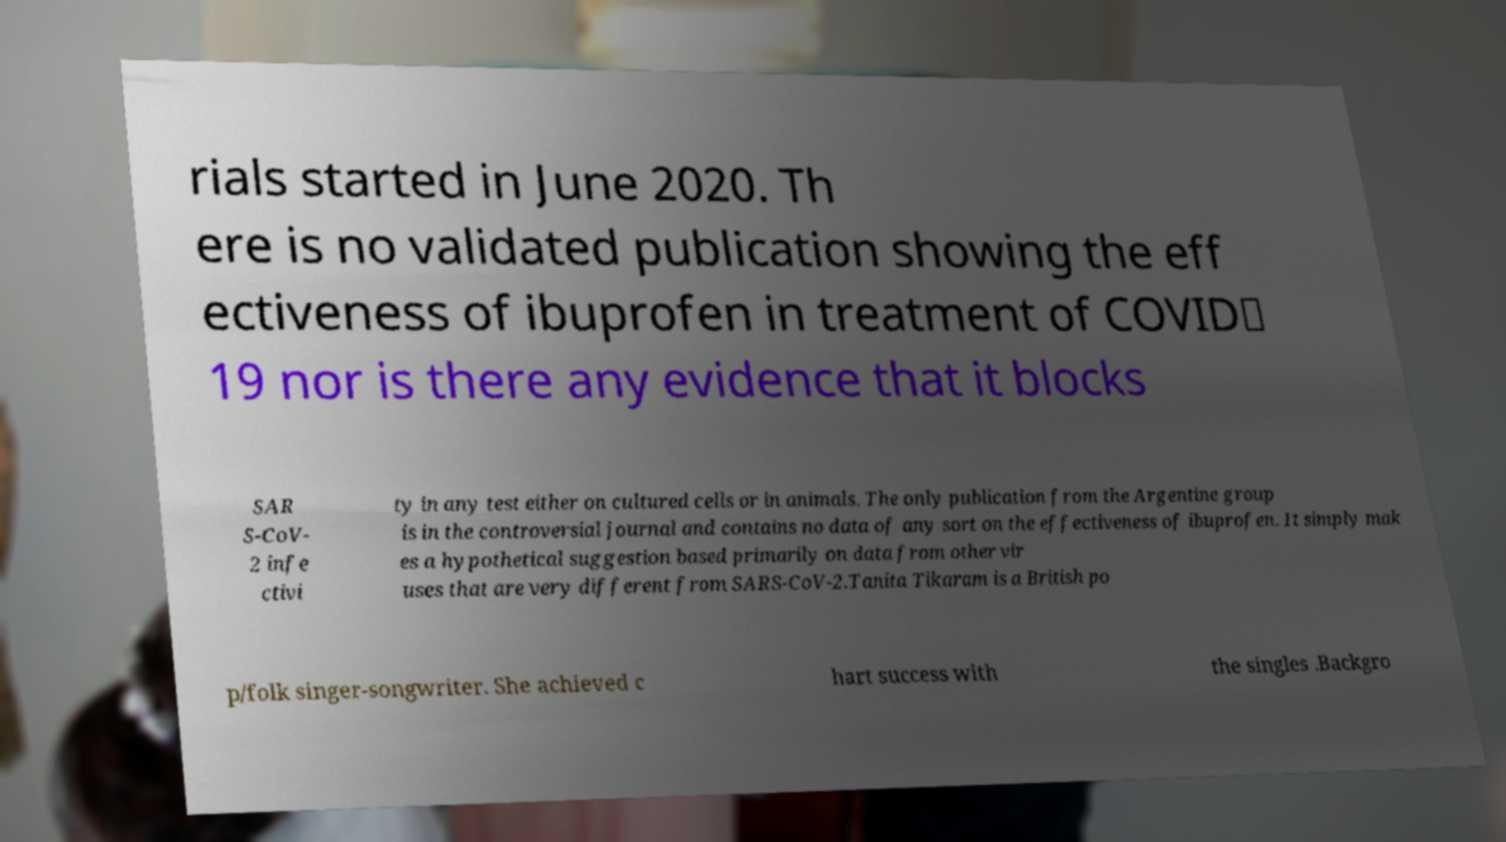There's text embedded in this image that I need extracted. Can you transcribe it verbatim? rials started in June 2020. Th ere is no validated publication showing the eff ectiveness of ibuprofen in treatment of COVID‑ 19 nor is there any evidence that it blocks SAR S-CoV- 2 infe ctivi ty in any test either on cultured cells or in animals. The only publication from the Argentine group is in the controversial journal and contains no data of any sort on the effectiveness of ibuprofen. It simply mak es a hypothetical suggestion based primarily on data from other vir uses that are very different from SARS-CoV-2.Tanita Tikaram is a British po p/folk singer-songwriter. She achieved c hart success with the singles .Backgro 